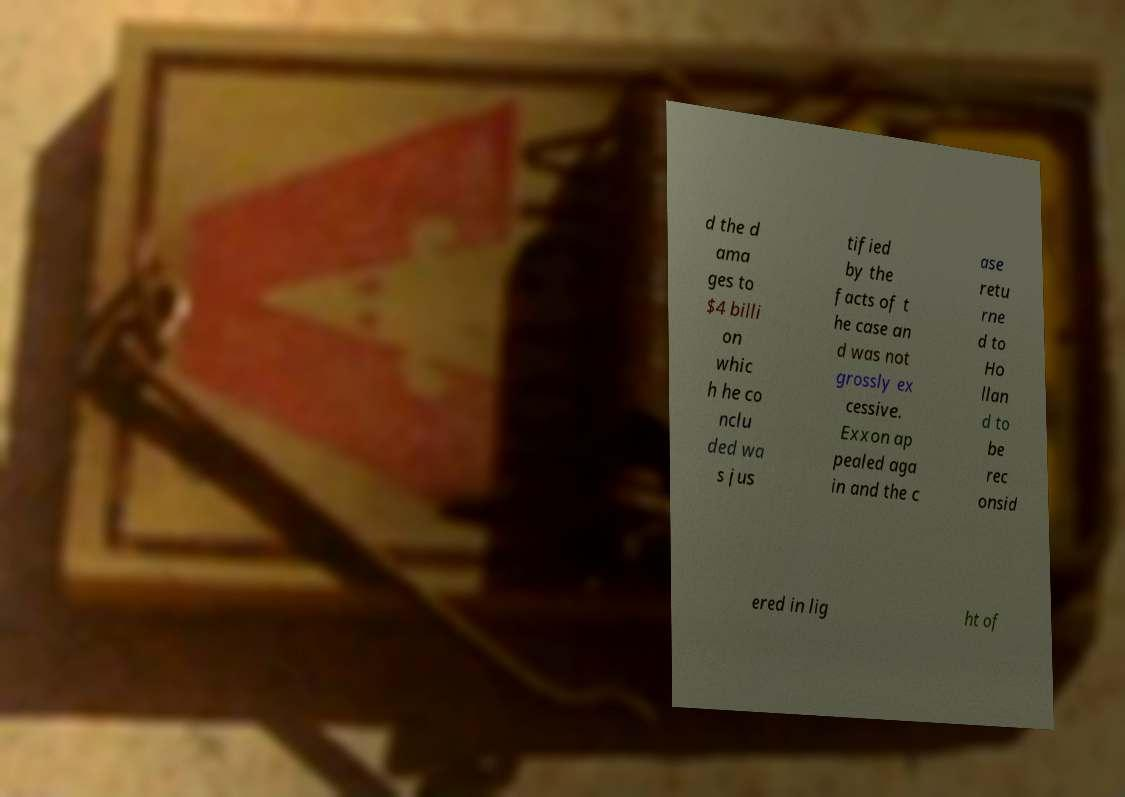Can you accurately transcribe the text from the provided image for me? d the d ama ges to $4 billi on whic h he co nclu ded wa s jus tified by the facts of t he case an d was not grossly ex cessive. Exxon ap pealed aga in and the c ase retu rne d to Ho llan d to be rec onsid ered in lig ht of 